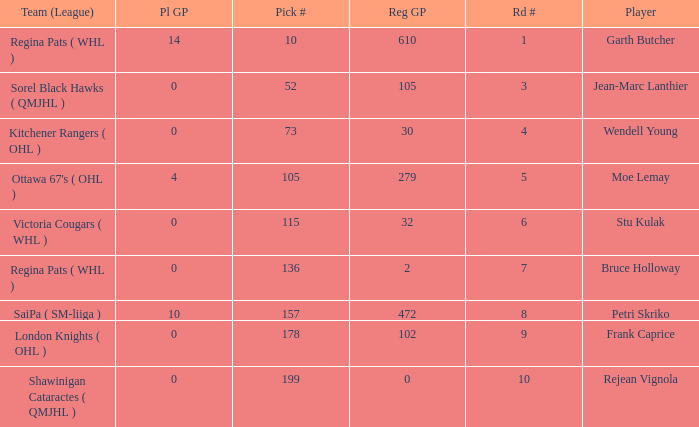What is the sum number of Pl GP when the pick number is 178 and the road number is bigger than 9? 0.0. 